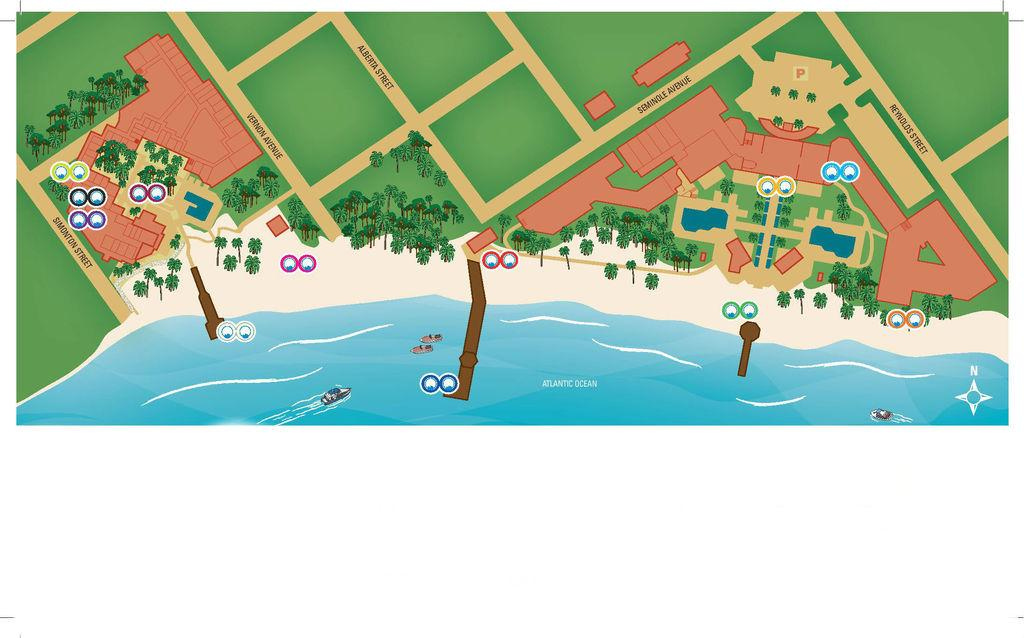What is the primary element visible in the image? There is water in the image. What is floating on the water in the image? There is a boat in the image. What type of vegetation can be seen in the image? There are trees in the image. What type of badge can be seen on the boat in the image? There is no badge present on the boat in the image. How many quarters are visible in the water in the image? There are no coins or quarters visible in the water in the image. 